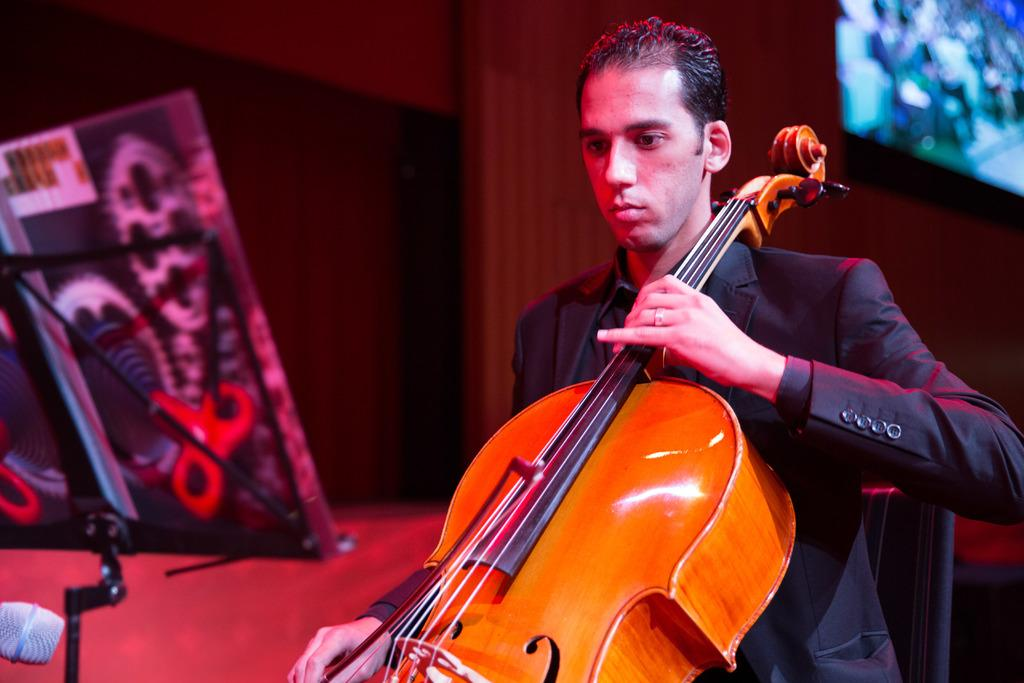What is the man in the image doing? The man is playing the violin. What object is in front of the man? There is a book stand in front of the man. Is there any reading material in the image? Yes, there is a book visible in the image. What type of bread is being toasted on the stove in the image? There is no bread or stove present in the image; it features a man playing the violin with a book stand and a book nearby. 